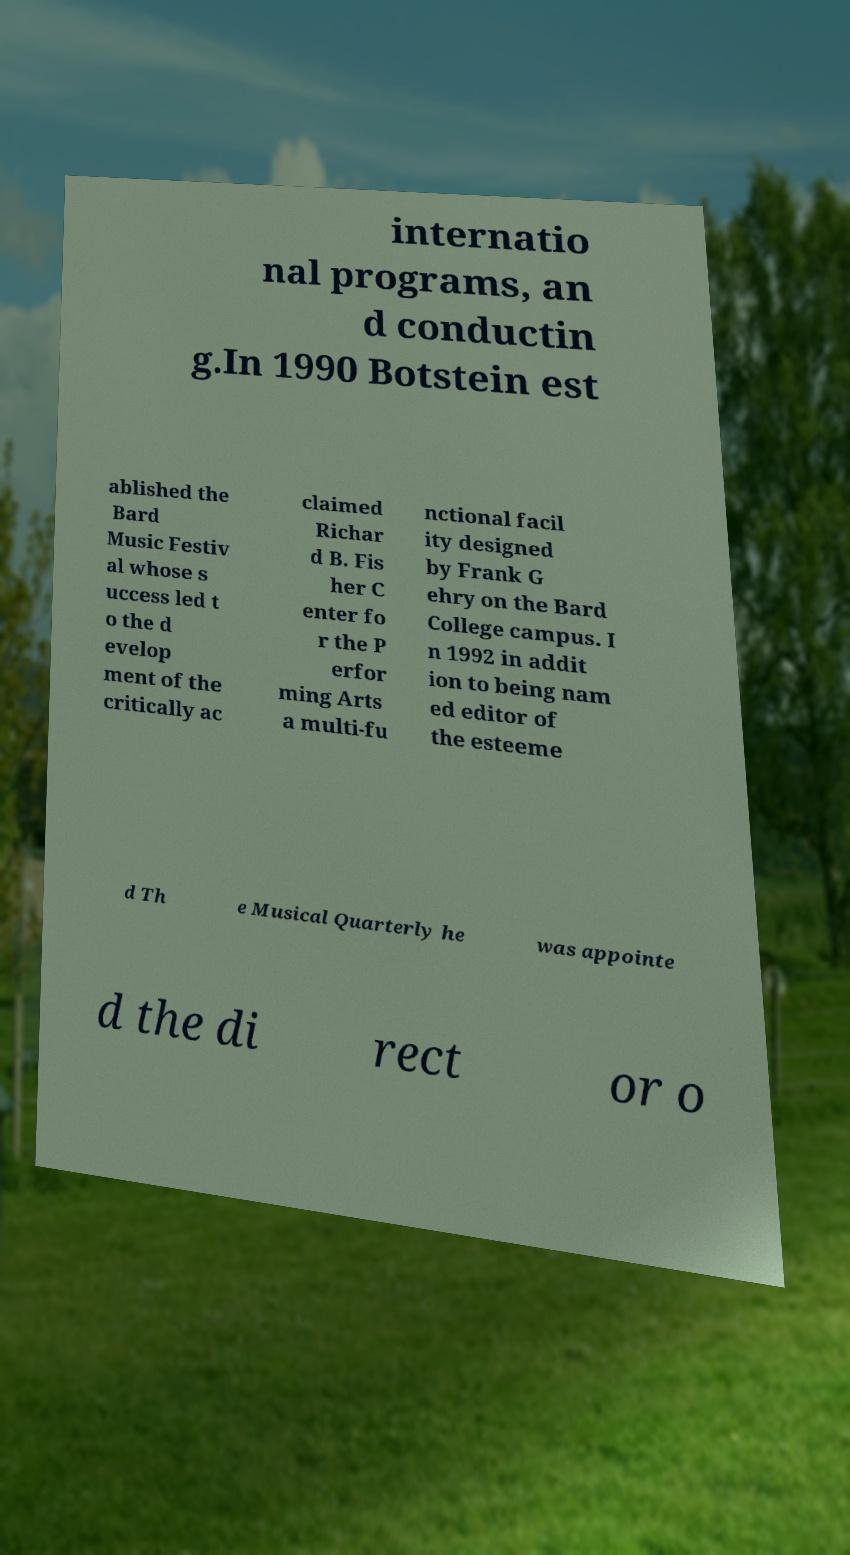Could you extract and type out the text from this image? internatio nal programs, an d conductin g.In 1990 Botstein est ablished the Bard Music Festiv al whose s uccess led t o the d evelop ment of the critically ac claimed Richar d B. Fis her C enter fo r the P erfor ming Arts a multi-fu nctional facil ity designed by Frank G ehry on the Bard College campus. I n 1992 in addit ion to being nam ed editor of the esteeme d Th e Musical Quarterly he was appointe d the di rect or o 